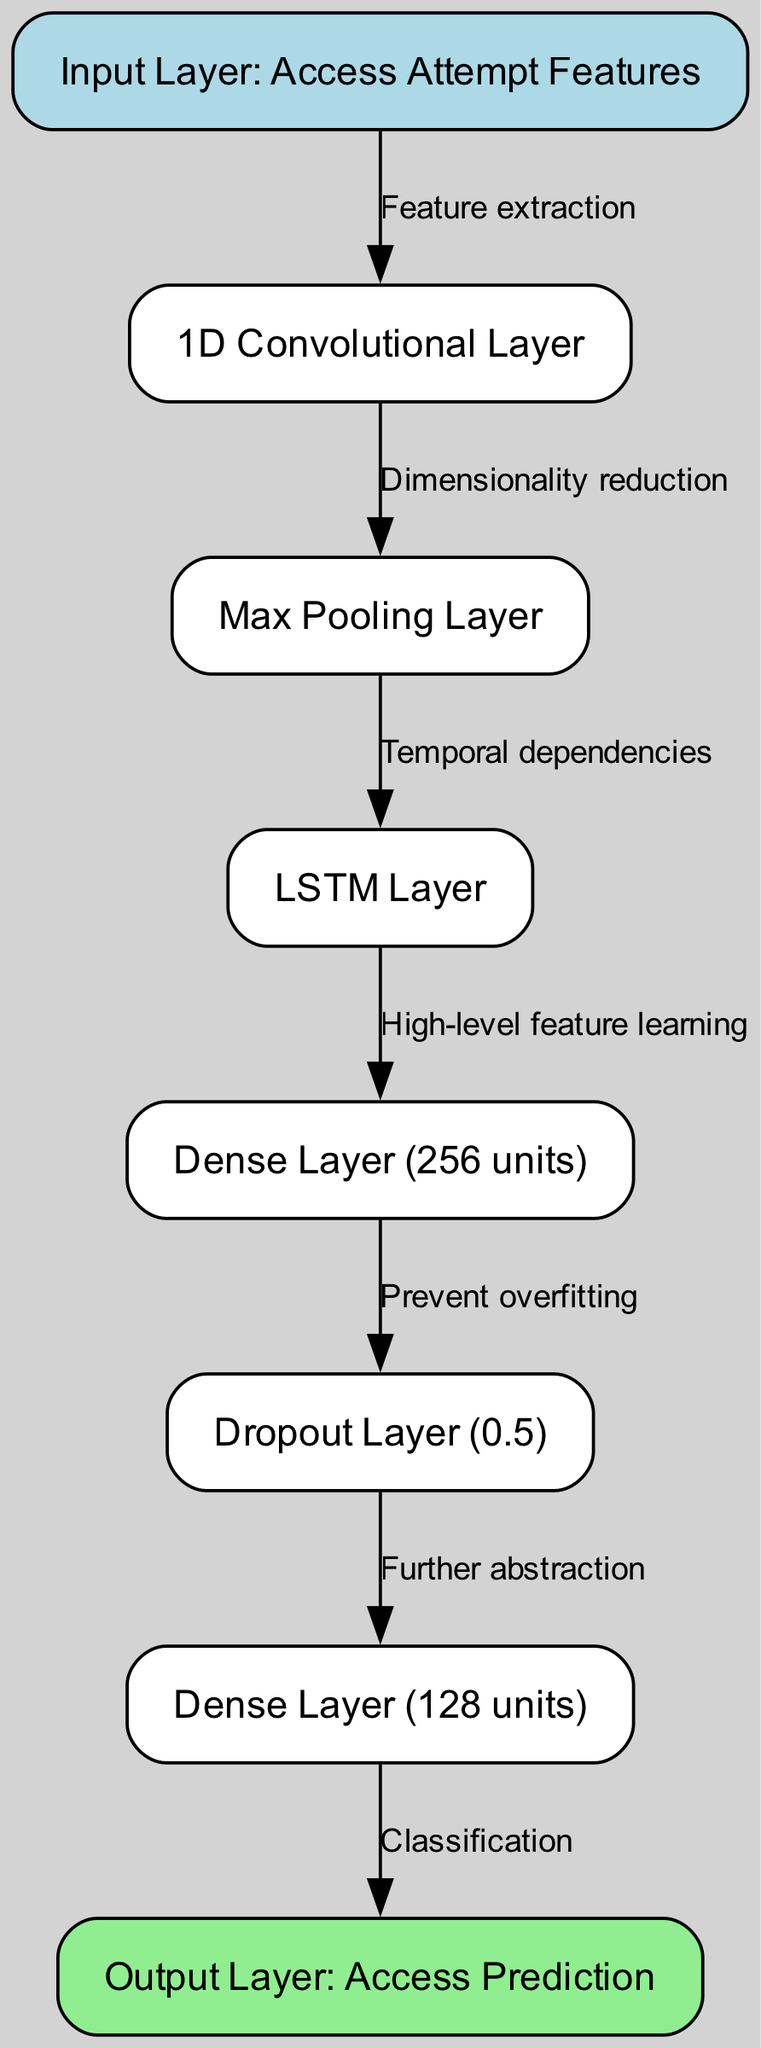What is the label of the first layer in the diagram? The first layer in the diagram is labeled as "Input Layer: Access Attempt Features." This information can be directly observed from the node labeled "input" in the diagram.
Answer: Input Layer: Access Attempt Features How many layers are there in total? By counting the nodes listed in the diagram, there are a total of 8 distinct layers (nodes). This includes the input layer, convolutional layer, pooling layer, LSTM layer, two dense layers, dropout layer, and the output layer.
Answer: 8 What type of layer follows the Max Pooling Layer? The layer that follows the Max Pooling Layer, according to the edges connecting the nodes, is the LSTM Layer. This is indicated by the directed edge from "pool1" to "lstm."
Answer: LSTM Layer What is the purpose of the Dropout Layer in this architecture? The Dropout Layer is specifically labeled "Prevent overfitting." This label indicates its intended function to mitigate overfitting during training by temporarily dropping units from the network.
Answer: Prevent overfitting How does the neural network perform classification? The neural network performs classification through the output layer, which is labeled "Output Layer: Access Prediction." The output from the preceding Dense Layer (128 units) is fed into this output layer for final classification.
Answer: Output Layer: Access Prediction Which layer is responsible for high-level feature learning? The layer identified as "Dense Layer (256 units)" is responsible for high-level feature learning, as indicated by the edge leading to it from the LSTM Layer with the label "High-level feature learning."
Answer: Dense Layer (256 units) What layer is immediately before the last layer? The layer immediately before the last layer (output layer) is "Dense Layer (128 units)," which receives input from the dropout layer prior to passing the information for classification.
Answer: Dense Layer (128 units) What relationship connects the Convolutional Layer to the Pooling Layer? The relationship between the Convolutional Layer and the Max Pooling Layer is described by the edge labeled "Dimensionality reduction," indicating the function or impact of the pooling layer following the convolutional processing.
Answer: Dimensionality reduction What is the dropout rate of the Dropout Layer? The Dropout Layer is labeled with a dropout rate of 0.5. This value signifies the proportion of units that are randomly dropped during training to prevent overfitting.
Answer: 0.5 